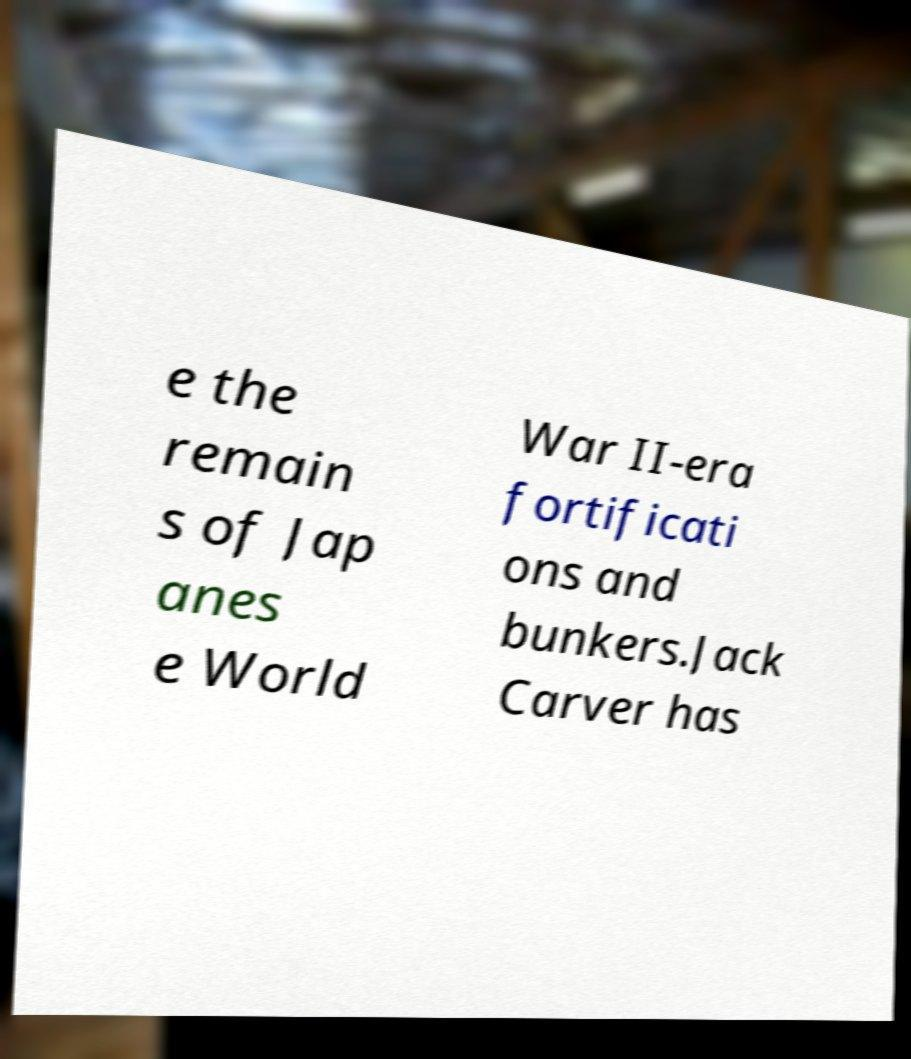Please identify and transcribe the text found in this image. e the remain s of Jap anes e World War II-era fortificati ons and bunkers.Jack Carver has 